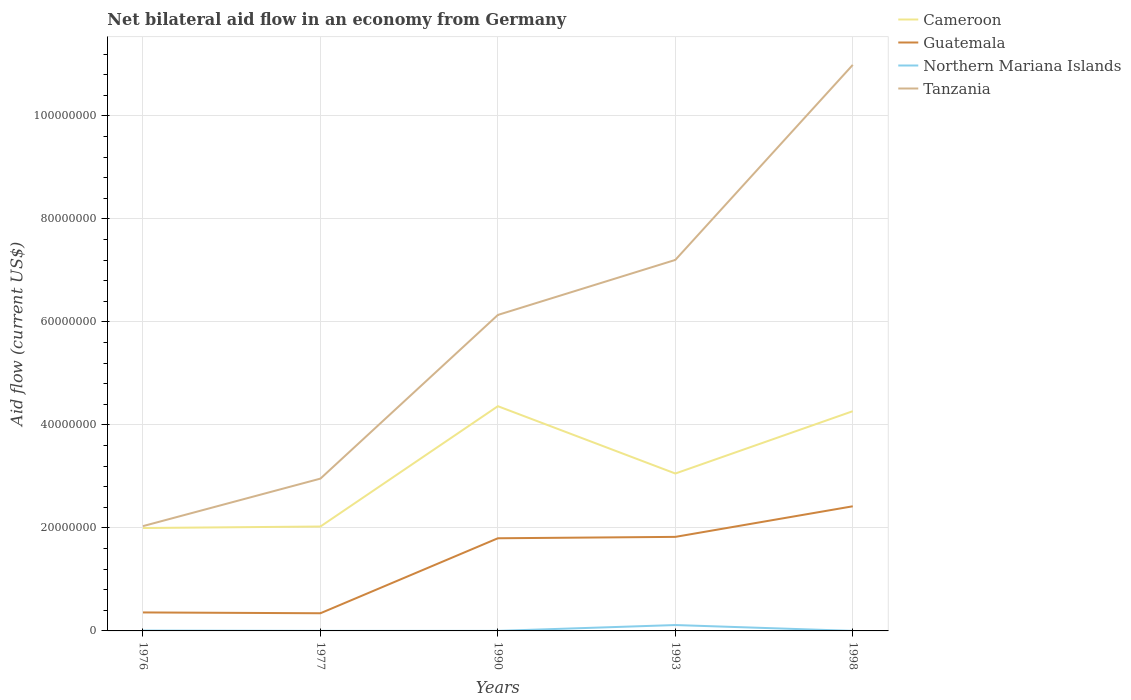Is the number of lines equal to the number of legend labels?
Offer a terse response. Yes. Across all years, what is the maximum net bilateral aid flow in Guatemala?
Ensure brevity in your answer.  3.43e+06. In which year was the net bilateral aid flow in Tanzania maximum?
Ensure brevity in your answer.  1976. What is the total net bilateral aid flow in Guatemala in the graph?
Provide a succinct answer. -1.48e+07. What is the difference between the highest and the second highest net bilateral aid flow in Tanzania?
Make the answer very short. 8.96e+07. How many lines are there?
Keep it short and to the point. 4. How many years are there in the graph?
Provide a succinct answer. 5. What is the difference between two consecutive major ticks on the Y-axis?
Your answer should be compact. 2.00e+07. Does the graph contain any zero values?
Provide a short and direct response. No. Where does the legend appear in the graph?
Your answer should be compact. Top right. How many legend labels are there?
Offer a very short reply. 4. What is the title of the graph?
Offer a terse response. Net bilateral aid flow in an economy from Germany. Does "West Bank and Gaza" appear as one of the legend labels in the graph?
Keep it short and to the point. No. What is the label or title of the X-axis?
Provide a succinct answer. Years. What is the Aid flow (current US$) of Cameroon in 1976?
Your answer should be very brief. 2.00e+07. What is the Aid flow (current US$) in Guatemala in 1976?
Your response must be concise. 3.59e+06. What is the Aid flow (current US$) in Tanzania in 1976?
Ensure brevity in your answer.  2.04e+07. What is the Aid flow (current US$) in Cameroon in 1977?
Provide a short and direct response. 2.03e+07. What is the Aid flow (current US$) of Guatemala in 1977?
Offer a very short reply. 3.43e+06. What is the Aid flow (current US$) in Northern Mariana Islands in 1977?
Your response must be concise. 10000. What is the Aid flow (current US$) of Tanzania in 1977?
Make the answer very short. 2.96e+07. What is the Aid flow (current US$) in Cameroon in 1990?
Your answer should be very brief. 4.36e+07. What is the Aid flow (current US$) of Guatemala in 1990?
Provide a succinct answer. 1.80e+07. What is the Aid flow (current US$) in Tanzania in 1990?
Ensure brevity in your answer.  6.14e+07. What is the Aid flow (current US$) of Cameroon in 1993?
Provide a succinct answer. 3.06e+07. What is the Aid flow (current US$) in Guatemala in 1993?
Give a very brief answer. 1.83e+07. What is the Aid flow (current US$) of Northern Mariana Islands in 1993?
Provide a succinct answer. 1.14e+06. What is the Aid flow (current US$) in Tanzania in 1993?
Provide a succinct answer. 7.20e+07. What is the Aid flow (current US$) in Cameroon in 1998?
Give a very brief answer. 4.27e+07. What is the Aid flow (current US$) in Guatemala in 1998?
Ensure brevity in your answer.  2.42e+07. What is the Aid flow (current US$) of Northern Mariana Islands in 1998?
Offer a very short reply. 10000. What is the Aid flow (current US$) in Tanzania in 1998?
Your response must be concise. 1.10e+08. Across all years, what is the maximum Aid flow (current US$) of Cameroon?
Ensure brevity in your answer.  4.36e+07. Across all years, what is the maximum Aid flow (current US$) of Guatemala?
Your answer should be very brief. 2.42e+07. Across all years, what is the maximum Aid flow (current US$) in Northern Mariana Islands?
Make the answer very short. 1.14e+06. Across all years, what is the maximum Aid flow (current US$) of Tanzania?
Provide a short and direct response. 1.10e+08. Across all years, what is the minimum Aid flow (current US$) in Cameroon?
Provide a succinct answer. 2.00e+07. Across all years, what is the minimum Aid flow (current US$) of Guatemala?
Provide a succinct answer. 3.43e+06. Across all years, what is the minimum Aid flow (current US$) in Northern Mariana Islands?
Ensure brevity in your answer.  10000. Across all years, what is the minimum Aid flow (current US$) in Tanzania?
Make the answer very short. 2.04e+07. What is the total Aid flow (current US$) in Cameroon in the graph?
Provide a succinct answer. 1.57e+08. What is the total Aid flow (current US$) of Guatemala in the graph?
Keep it short and to the point. 6.75e+07. What is the total Aid flow (current US$) in Northern Mariana Islands in the graph?
Provide a succinct answer. 1.24e+06. What is the total Aid flow (current US$) of Tanzania in the graph?
Give a very brief answer. 2.93e+08. What is the difference between the Aid flow (current US$) of Cameroon in 1976 and that in 1977?
Ensure brevity in your answer.  -2.90e+05. What is the difference between the Aid flow (current US$) in Tanzania in 1976 and that in 1977?
Keep it short and to the point. -9.22e+06. What is the difference between the Aid flow (current US$) of Cameroon in 1976 and that in 1990?
Offer a terse response. -2.36e+07. What is the difference between the Aid flow (current US$) in Guatemala in 1976 and that in 1990?
Provide a short and direct response. -1.44e+07. What is the difference between the Aid flow (current US$) in Northern Mariana Islands in 1976 and that in 1990?
Give a very brief answer. 6.00e+04. What is the difference between the Aid flow (current US$) of Tanzania in 1976 and that in 1990?
Provide a short and direct response. -4.10e+07. What is the difference between the Aid flow (current US$) in Cameroon in 1976 and that in 1993?
Offer a very short reply. -1.06e+07. What is the difference between the Aid flow (current US$) of Guatemala in 1976 and that in 1993?
Keep it short and to the point. -1.47e+07. What is the difference between the Aid flow (current US$) of Northern Mariana Islands in 1976 and that in 1993?
Offer a terse response. -1.07e+06. What is the difference between the Aid flow (current US$) of Tanzania in 1976 and that in 1993?
Keep it short and to the point. -5.17e+07. What is the difference between the Aid flow (current US$) of Cameroon in 1976 and that in 1998?
Make the answer very short. -2.27e+07. What is the difference between the Aid flow (current US$) of Guatemala in 1976 and that in 1998?
Your answer should be very brief. -2.06e+07. What is the difference between the Aid flow (current US$) in Tanzania in 1976 and that in 1998?
Provide a short and direct response. -8.96e+07. What is the difference between the Aid flow (current US$) in Cameroon in 1977 and that in 1990?
Make the answer very short. -2.34e+07. What is the difference between the Aid flow (current US$) of Guatemala in 1977 and that in 1990?
Keep it short and to the point. -1.46e+07. What is the difference between the Aid flow (current US$) of Northern Mariana Islands in 1977 and that in 1990?
Give a very brief answer. 0. What is the difference between the Aid flow (current US$) of Tanzania in 1977 and that in 1990?
Make the answer very short. -3.18e+07. What is the difference between the Aid flow (current US$) of Cameroon in 1977 and that in 1993?
Your response must be concise. -1.03e+07. What is the difference between the Aid flow (current US$) in Guatemala in 1977 and that in 1993?
Provide a short and direct response. -1.48e+07. What is the difference between the Aid flow (current US$) in Northern Mariana Islands in 1977 and that in 1993?
Keep it short and to the point. -1.13e+06. What is the difference between the Aid flow (current US$) in Tanzania in 1977 and that in 1993?
Offer a terse response. -4.25e+07. What is the difference between the Aid flow (current US$) of Cameroon in 1977 and that in 1998?
Your answer should be very brief. -2.24e+07. What is the difference between the Aid flow (current US$) in Guatemala in 1977 and that in 1998?
Provide a succinct answer. -2.08e+07. What is the difference between the Aid flow (current US$) of Tanzania in 1977 and that in 1998?
Provide a succinct answer. -8.03e+07. What is the difference between the Aid flow (current US$) of Cameroon in 1990 and that in 1993?
Keep it short and to the point. 1.31e+07. What is the difference between the Aid flow (current US$) of Guatemala in 1990 and that in 1993?
Offer a very short reply. -2.70e+05. What is the difference between the Aid flow (current US$) in Northern Mariana Islands in 1990 and that in 1993?
Provide a succinct answer. -1.13e+06. What is the difference between the Aid flow (current US$) of Tanzania in 1990 and that in 1993?
Your answer should be compact. -1.07e+07. What is the difference between the Aid flow (current US$) of Cameroon in 1990 and that in 1998?
Give a very brief answer. 9.70e+05. What is the difference between the Aid flow (current US$) in Guatemala in 1990 and that in 1998?
Keep it short and to the point. -6.21e+06. What is the difference between the Aid flow (current US$) in Northern Mariana Islands in 1990 and that in 1998?
Your response must be concise. 0. What is the difference between the Aid flow (current US$) of Tanzania in 1990 and that in 1998?
Offer a very short reply. -4.86e+07. What is the difference between the Aid flow (current US$) of Cameroon in 1993 and that in 1998?
Provide a short and direct response. -1.21e+07. What is the difference between the Aid flow (current US$) in Guatemala in 1993 and that in 1998?
Ensure brevity in your answer.  -5.94e+06. What is the difference between the Aid flow (current US$) in Northern Mariana Islands in 1993 and that in 1998?
Ensure brevity in your answer.  1.13e+06. What is the difference between the Aid flow (current US$) in Tanzania in 1993 and that in 1998?
Provide a succinct answer. -3.79e+07. What is the difference between the Aid flow (current US$) in Cameroon in 1976 and the Aid flow (current US$) in Guatemala in 1977?
Ensure brevity in your answer.  1.66e+07. What is the difference between the Aid flow (current US$) of Cameroon in 1976 and the Aid flow (current US$) of Northern Mariana Islands in 1977?
Offer a very short reply. 2.00e+07. What is the difference between the Aid flow (current US$) of Cameroon in 1976 and the Aid flow (current US$) of Tanzania in 1977?
Your response must be concise. -9.59e+06. What is the difference between the Aid flow (current US$) in Guatemala in 1976 and the Aid flow (current US$) in Northern Mariana Islands in 1977?
Provide a short and direct response. 3.58e+06. What is the difference between the Aid flow (current US$) of Guatemala in 1976 and the Aid flow (current US$) of Tanzania in 1977?
Offer a terse response. -2.60e+07. What is the difference between the Aid flow (current US$) in Northern Mariana Islands in 1976 and the Aid flow (current US$) in Tanzania in 1977?
Your answer should be compact. -2.95e+07. What is the difference between the Aid flow (current US$) of Cameroon in 1976 and the Aid flow (current US$) of Guatemala in 1990?
Offer a very short reply. 1.99e+06. What is the difference between the Aid flow (current US$) of Cameroon in 1976 and the Aid flow (current US$) of Northern Mariana Islands in 1990?
Give a very brief answer. 2.00e+07. What is the difference between the Aid flow (current US$) of Cameroon in 1976 and the Aid flow (current US$) of Tanzania in 1990?
Provide a succinct answer. -4.14e+07. What is the difference between the Aid flow (current US$) of Guatemala in 1976 and the Aid flow (current US$) of Northern Mariana Islands in 1990?
Your response must be concise. 3.58e+06. What is the difference between the Aid flow (current US$) of Guatemala in 1976 and the Aid flow (current US$) of Tanzania in 1990?
Offer a very short reply. -5.78e+07. What is the difference between the Aid flow (current US$) of Northern Mariana Islands in 1976 and the Aid flow (current US$) of Tanzania in 1990?
Offer a very short reply. -6.13e+07. What is the difference between the Aid flow (current US$) of Cameroon in 1976 and the Aid flow (current US$) of Guatemala in 1993?
Offer a terse response. 1.72e+06. What is the difference between the Aid flow (current US$) of Cameroon in 1976 and the Aid flow (current US$) of Northern Mariana Islands in 1993?
Offer a very short reply. 1.88e+07. What is the difference between the Aid flow (current US$) of Cameroon in 1976 and the Aid flow (current US$) of Tanzania in 1993?
Ensure brevity in your answer.  -5.20e+07. What is the difference between the Aid flow (current US$) in Guatemala in 1976 and the Aid flow (current US$) in Northern Mariana Islands in 1993?
Give a very brief answer. 2.45e+06. What is the difference between the Aid flow (current US$) of Guatemala in 1976 and the Aid flow (current US$) of Tanzania in 1993?
Your answer should be compact. -6.84e+07. What is the difference between the Aid flow (current US$) in Northern Mariana Islands in 1976 and the Aid flow (current US$) in Tanzania in 1993?
Provide a succinct answer. -7.20e+07. What is the difference between the Aid flow (current US$) of Cameroon in 1976 and the Aid flow (current US$) of Guatemala in 1998?
Your answer should be very brief. -4.22e+06. What is the difference between the Aid flow (current US$) of Cameroon in 1976 and the Aid flow (current US$) of Northern Mariana Islands in 1998?
Make the answer very short. 2.00e+07. What is the difference between the Aid flow (current US$) in Cameroon in 1976 and the Aid flow (current US$) in Tanzania in 1998?
Offer a terse response. -8.99e+07. What is the difference between the Aid flow (current US$) in Guatemala in 1976 and the Aid flow (current US$) in Northern Mariana Islands in 1998?
Offer a terse response. 3.58e+06. What is the difference between the Aid flow (current US$) in Guatemala in 1976 and the Aid flow (current US$) in Tanzania in 1998?
Provide a short and direct response. -1.06e+08. What is the difference between the Aid flow (current US$) of Northern Mariana Islands in 1976 and the Aid flow (current US$) of Tanzania in 1998?
Give a very brief answer. -1.10e+08. What is the difference between the Aid flow (current US$) in Cameroon in 1977 and the Aid flow (current US$) in Guatemala in 1990?
Your answer should be compact. 2.28e+06. What is the difference between the Aid flow (current US$) of Cameroon in 1977 and the Aid flow (current US$) of Northern Mariana Islands in 1990?
Your answer should be very brief. 2.03e+07. What is the difference between the Aid flow (current US$) in Cameroon in 1977 and the Aid flow (current US$) in Tanzania in 1990?
Provide a short and direct response. -4.11e+07. What is the difference between the Aid flow (current US$) of Guatemala in 1977 and the Aid flow (current US$) of Northern Mariana Islands in 1990?
Give a very brief answer. 3.42e+06. What is the difference between the Aid flow (current US$) of Guatemala in 1977 and the Aid flow (current US$) of Tanzania in 1990?
Provide a succinct answer. -5.79e+07. What is the difference between the Aid flow (current US$) of Northern Mariana Islands in 1977 and the Aid flow (current US$) of Tanzania in 1990?
Provide a short and direct response. -6.13e+07. What is the difference between the Aid flow (current US$) of Cameroon in 1977 and the Aid flow (current US$) of Guatemala in 1993?
Keep it short and to the point. 2.01e+06. What is the difference between the Aid flow (current US$) of Cameroon in 1977 and the Aid flow (current US$) of Northern Mariana Islands in 1993?
Ensure brevity in your answer.  1.91e+07. What is the difference between the Aid flow (current US$) in Cameroon in 1977 and the Aid flow (current US$) in Tanzania in 1993?
Provide a short and direct response. -5.18e+07. What is the difference between the Aid flow (current US$) of Guatemala in 1977 and the Aid flow (current US$) of Northern Mariana Islands in 1993?
Provide a short and direct response. 2.29e+06. What is the difference between the Aid flow (current US$) of Guatemala in 1977 and the Aid flow (current US$) of Tanzania in 1993?
Provide a short and direct response. -6.86e+07. What is the difference between the Aid flow (current US$) of Northern Mariana Islands in 1977 and the Aid flow (current US$) of Tanzania in 1993?
Your answer should be very brief. -7.20e+07. What is the difference between the Aid flow (current US$) of Cameroon in 1977 and the Aid flow (current US$) of Guatemala in 1998?
Your answer should be compact. -3.93e+06. What is the difference between the Aid flow (current US$) in Cameroon in 1977 and the Aid flow (current US$) in Northern Mariana Islands in 1998?
Provide a short and direct response. 2.03e+07. What is the difference between the Aid flow (current US$) in Cameroon in 1977 and the Aid flow (current US$) in Tanzania in 1998?
Your answer should be compact. -8.96e+07. What is the difference between the Aid flow (current US$) of Guatemala in 1977 and the Aid flow (current US$) of Northern Mariana Islands in 1998?
Your answer should be very brief. 3.42e+06. What is the difference between the Aid flow (current US$) of Guatemala in 1977 and the Aid flow (current US$) of Tanzania in 1998?
Your answer should be very brief. -1.06e+08. What is the difference between the Aid flow (current US$) in Northern Mariana Islands in 1977 and the Aid flow (current US$) in Tanzania in 1998?
Provide a short and direct response. -1.10e+08. What is the difference between the Aid flow (current US$) in Cameroon in 1990 and the Aid flow (current US$) in Guatemala in 1993?
Ensure brevity in your answer.  2.54e+07. What is the difference between the Aid flow (current US$) in Cameroon in 1990 and the Aid flow (current US$) in Northern Mariana Islands in 1993?
Make the answer very short. 4.25e+07. What is the difference between the Aid flow (current US$) of Cameroon in 1990 and the Aid flow (current US$) of Tanzania in 1993?
Provide a succinct answer. -2.84e+07. What is the difference between the Aid flow (current US$) in Guatemala in 1990 and the Aid flow (current US$) in Northern Mariana Islands in 1993?
Your answer should be compact. 1.68e+07. What is the difference between the Aid flow (current US$) in Guatemala in 1990 and the Aid flow (current US$) in Tanzania in 1993?
Give a very brief answer. -5.40e+07. What is the difference between the Aid flow (current US$) in Northern Mariana Islands in 1990 and the Aid flow (current US$) in Tanzania in 1993?
Your answer should be compact. -7.20e+07. What is the difference between the Aid flow (current US$) in Cameroon in 1990 and the Aid flow (current US$) in Guatemala in 1998?
Ensure brevity in your answer.  1.94e+07. What is the difference between the Aid flow (current US$) in Cameroon in 1990 and the Aid flow (current US$) in Northern Mariana Islands in 1998?
Make the answer very short. 4.36e+07. What is the difference between the Aid flow (current US$) of Cameroon in 1990 and the Aid flow (current US$) of Tanzania in 1998?
Provide a short and direct response. -6.63e+07. What is the difference between the Aid flow (current US$) of Guatemala in 1990 and the Aid flow (current US$) of Northern Mariana Islands in 1998?
Provide a short and direct response. 1.80e+07. What is the difference between the Aid flow (current US$) in Guatemala in 1990 and the Aid flow (current US$) in Tanzania in 1998?
Your response must be concise. -9.19e+07. What is the difference between the Aid flow (current US$) of Northern Mariana Islands in 1990 and the Aid flow (current US$) of Tanzania in 1998?
Offer a terse response. -1.10e+08. What is the difference between the Aid flow (current US$) of Cameroon in 1993 and the Aid flow (current US$) of Guatemala in 1998?
Provide a short and direct response. 6.36e+06. What is the difference between the Aid flow (current US$) of Cameroon in 1993 and the Aid flow (current US$) of Northern Mariana Islands in 1998?
Make the answer very short. 3.06e+07. What is the difference between the Aid flow (current US$) in Cameroon in 1993 and the Aid flow (current US$) in Tanzania in 1998?
Your response must be concise. -7.93e+07. What is the difference between the Aid flow (current US$) of Guatemala in 1993 and the Aid flow (current US$) of Northern Mariana Islands in 1998?
Your answer should be very brief. 1.82e+07. What is the difference between the Aid flow (current US$) in Guatemala in 1993 and the Aid flow (current US$) in Tanzania in 1998?
Make the answer very short. -9.16e+07. What is the difference between the Aid flow (current US$) in Northern Mariana Islands in 1993 and the Aid flow (current US$) in Tanzania in 1998?
Ensure brevity in your answer.  -1.09e+08. What is the average Aid flow (current US$) of Cameroon per year?
Give a very brief answer. 3.14e+07. What is the average Aid flow (current US$) in Guatemala per year?
Offer a terse response. 1.35e+07. What is the average Aid flow (current US$) in Northern Mariana Islands per year?
Provide a short and direct response. 2.48e+05. What is the average Aid flow (current US$) of Tanzania per year?
Your answer should be compact. 5.86e+07. In the year 1976, what is the difference between the Aid flow (current US$) in Cameroon and Aid flow (current US$) in Guatemala?
Make the answer very short. 1.64e+07. In the year 1976, what is the difference between the Aid flow (current US$) of Cameroon and Aid flow (current US$) of Northern Mariana Islands?
Make the answer very short. 1.99e+07. In the year 1976, what is the difference between the Aid flow (current US$) of Cameroon and Aid flow (current US$) of Tanzania?
Offer a very short reply. -3.70e+05. In the year 1976, what is the difference between the Aid flow (current US$) of Guatemala and Aid flow (current US$) of Northern Mariana Islands?
Keep it short and to the point. 3.52e+06. In the year 1976, what is the difference between the Aid flow (current US$) in Guatemala and Aid flow (current US$) in Tanzania?
Offer a very short reply. -1.68e+07. In the year 1976, what is the difference between the Aid flow (current US$) in Northern Mariana Islands and Aid flow (current US$) in Tanzania?
Your answer should be very brief. -2.03e+07. In the year 1977, what is the difference between the Aid flow (current US$) of Cameroon and Aid flow (current US$) of Guatemala?
Provide a short and direct response. 1.68e+07. In the year 1977, what is the difference between the Aid flow (current US$) in Cameroon and Aid flow (current US$) in Northern Mariana Islands?
Offer a terse response. 2.03e+07. In the year 1977, what is the difference between the Aid flow (current US$) of Cameroon and Aid flow (current US$) of Tanzania?
Your response must be concise. -9.30e+06. In the year 1977, what is the difference between the Aid flow (current US$) of Guatemala and Aid flow (current US$) of Northern Mariana Islands?
Provide a succinct answer. 3.42e+06. In the year 1977, what is the difference between the Aid flow (current US$) of Guatemala and Aid flow (current US$) of Tanzania?
Your answer should be compact. -2.61e+07. In the year 1977, what is the difference between the Aid flow (current US$) of Northern Mariana Islands and Aid flow (current US$) of Tanzania?
Your answer should be very brief. -2.96e+07. In the year 1990, what is the difference between the Aid flow (current US$) of Cameroon and Aid flow (current US$) of Guatemala?
Provide a short and direct response. 2.56e+07. In the year 1990, what is the difference between the Aid flow (current US$) of Cameroon and Aid flow (current US$) of Northern Mariana Islands?
Provide a succinct answer. 4.36e+07. In the year 1990, what is the difference between the Aid flow (current US$) of Cameroon and Aid flow (current US$) of Tanzania?
Offer a terse response. -1.77e+07. In the year 1990, what is the difference between the Aid flow (current US$) in Guatemala and Aid flow (current US$) in Northern Mariana Islands?
Offer a very short reply. 1.80e+07. In the year 1990, what is the difference between the Aid flow (current US$) in Guatemala and Aid flow (current US$) in Tanzania?
Offer a very short reply. -4.34e+07. In the year 1990, what is the difference between the Aid flow (current US$) of Northern Mariana Islands and Aid flow (current US$) of Tanzania?
Offer a terse response. -6.13e+07. In the year 1993, what is the difference between the Aid flow (current US$) of Cameroon and Aid flow (current US$) of Guatemala?
Ensure brevity in your answer.  1.23e+07. In the year 1993, what is the difference between the Aid flow (current US$) of Cameroon and Aid flow (current US$) of Northern Mariana Islands?
Your answer should be very brief. 2.94e+07. In the year 1993, what is the difference between the Aid flow (current US$) of Cameroon and Aid flow (current US$) of Tanzania?
Offer a very short reply. -4.15e+07. In the year 1993, what is the difference between the Aid flow (current US$) of Guatemala and Aid flow (current US$) of Northern Mariana Islands?
Your answer should be very brief. 1.71e+07. In the year 1993, what is the difference between the Aid flow (current US$) of Guatemala and Aid flow (current US$) of Tanzania?
Provide a short and direct response. -5.38e+07. In the year 1993, what is the difference between the Aid flow (current US$) in Northern Mariana Islands and Aid flow (current US$) in Tanzania?
Your answer should be compact. -7.09e+07. In the year 1998, what is the difference between the Aid flow (current US$) of Cameroon and Aid flow (current US$) of Guatemala?
Ensure brevity in your answer.  1.85e+07. In the year 1998, what is the difference between the Aid flow (current US$) in Cameroon and Aid flow (current US$) in Northern Mariana Islands?
Your response must be concise. 4.26e+07. In the year 1998, what is the difference between the Aid flow (current US$) of Cameroon and Aid flow (current US$) of Tanzania?
Keep it short and to the point. -6.72e+07. In the year 1998, what is the difference between the Aid flow (current US$) of Guatemala and Aid flow (current US$) of Northern Mariana Islands?
Your answer should be very brief. 2.42e+07. In the year 1998, what is the difference between the Aid flow (current US$) of Guatemala and Aid flow (current US$) of Tanzania?
Keep it short and to the point. -8.57e+07. In the year 1998, what is the difference between the Aid flow (current US$) of Northern Mariana Islands and Aid flow (current US$) of Tanzania?
Your answer should be compact. -1.10e+08. What is the ratio of the Aid flow (current US$) of Cameroon in 1976 to that in 1977?
Your response must be concise. 0.99. What is the ratio of the Aid flow (current US$) in Guatemala in 1976 to that in 1977?
Your answer should be very brief. 1.05. What is the ratio of the Aid flow (current US$) of Northern Mariana Islands in 1976 to that in 1977?
Your response must be concise. 7. What is the ratio of the Aid flow (current US$) of Tanzania in 1976 to that in 1977?
Provide a succinct answer. 0.69. What is the ratio of the Aid flow (current US$) of Cameroon in 1976 to that in 1990?
Offer a very short reply. 0.46. What is the ratio of the Aid flow (current US$) in Guatemala in 1976 to that in 1990?
Provide a succinct answer. 0.2. What is the ratio of the Aid flow (current US$) of Northern Mariana Islands in 1976 to that in 1990?
Offer a terse response. 7. What is the ratio of the Aid flow (current US$) in Tanzania in 1976 to that in 1990?
Your answer should be compact. 0.33. What is the ratio of the Aid flow (current US$) in Cameroon in 1976 to that in 1993?
Your response must be concise. 0.65. What is the ratio of the Aid flow (current US$) of Guatemala in 1976 to that in 1993?
Make the answer very short. 0.2. What is the ratio of the Aid flow (current US$) in Northern Mariana Islands in 1976 to that in 1993?
Offer a terse response. 0.06. What is the ratio of the Aid flow (current US$) in Tanzania in 1976 to that in 1993?
Give a very brief answer. 0.28. What is the ratio of the Aid flow (current US$) of Cameroon in 1976 to that in 1998?
Offer a very short reply. 0.47. What is the ratio of the Aid flow (current US$) of Guatemala in 1976 to that in 1998?
Keep it short and to the point. 0.15. What is the ratio of the Aid flow (current US$) of Tanzania in 1976 to that in 1998?
Ensure brevity in your answer.  0.19. What is the ratio of the Aid flow (current US$) in Cameroon in 1977 to that in 1990?
Provide a succinct answer. 0.46. What is the ratio of the Aid flow (current US$) of Guatemala in 1977 to that in 1990?
Offer a terse response. 0.19. What is the ratio of the Aid flow (current US$) of Tanzania in 1977 to that in 1990?
Provide a short and direct response. 0.48. What is the ratio of the Aid flow (current US$) of Cameroon in 1977 to that in 1993?
Provide a succinct answer. 0.66. What is the ratio of the Aid flow (current US$) of Guatemala in 1977 to that in 1993?
Provide a short and direct response. 0.19. What is the ratio of the Aid flow (current US$) in Northern Mariana Islands in 1977 to that in 1993?
Keep it short and to the point. 0.01. What is the ratio of the Aid flow (current US$) of Tanzania in 1977 to that in 1993?
Keep it short and to the point. 0.41. What is the ratio of the Aid flow (current US$) of Cameroon in 1977 to that in 1998?
Ensure brevity in your answer.  0.48. What is the ratio of the Aid flow (current US$) of Guatemala in 1977 to that in 1998?
Your answer should be compact. 0.14. What is the ratio of the Aid flow (current US$) of Tanzania in 1977 to that in 1998?
Offer a very short reply. 0.27. What is the ratio of the Aid flow (current US$) in Cameroon in 1990 to that in 1993?
Offer a terse response. 1.43. What is the ratio of the Aid flow (current US$) in Guatemala in 1990 to that in 1993?
Keep it short and to the point. 0.99. What is the ratio of the Aid flow (current US$) in Northern Mariana Islands in 1990 to that in 1993?
Provide a succinct answer. 0.01. What is the ratio of the Aid flow (current US$) of Tanzania in 1990 to that in 1993?
Keep it short and to the point. 0.85. What is the ratio of the Aid flow (current US$) in Cameroon in 1990 to that in 1998?
Offer a terse response. 1.02. What is the ratio of the Aid flow (current US$) of Guatemala in 1990 to that in 1998?
Make the answer very short. 0.74. What is the ratio of the Aid flow (current US$) in Northern Mariana Islands in 1990 to that in 1998?
Provide a succinct answer. 1. What is the ratio of the Aid flow (current US$) of Tanzania in 1990 to that in 1998?
Ensure brevity in your answer.  0.56. What is the ratio of the Aid flow (current US$) of Cameroon in 1993 to that in 1998?
Give a very brief answer. 0.72. What is the ratio of the Aid flow (current US$) in Guatemala in 1993 to that in 1998?
Your answer should be compact. 0.75. What is the ratio of the Aid flow (current US$) of Northern Mariana Islands in 1993 to that in 1998?
Provide a short and direct response. 114. What is the ratio of the Aid flow (current US$) in Tanzania in 1993 to that in 1998?
Provide a short and direct response. 0.66. What is the difference between the highest and the second highest Aid flow (current US$) of Cameroon?
Your answer should be compact. 9.70e+05. What is the difference between the highest and the second highest Aid flow (current US$) of Guatemala?
Offer a terse response. 5.94e+06. What is the difference between the highest and the second highest Aid flow (current US$) in Northern Mariana Islands?
Offer a very short reply. 1.07e+06. What is the difference between the highest and the second highest Aid flow (current US$) of Tanzania?
Your answer should be compact. 3.79e+07. What is the difference between the highest and the lowest Aid flow (current US$) in Cameroon?
Offer a very short reply. 2.36e+07. What is the difference between the highest and the lowest Aid flow (current US$) in Guatemala?
Provide a succinct answer. 2.08e+07. What is the difference between the highest and the lowest Aid flow (current US$) in Northern Mariana Islands?
Your response must be concise. 1.13e+06. What is the difference between the highest and the lowest Aid flow (current US$) in Tanzania?
Your response must be concise. 8.96e+07. 